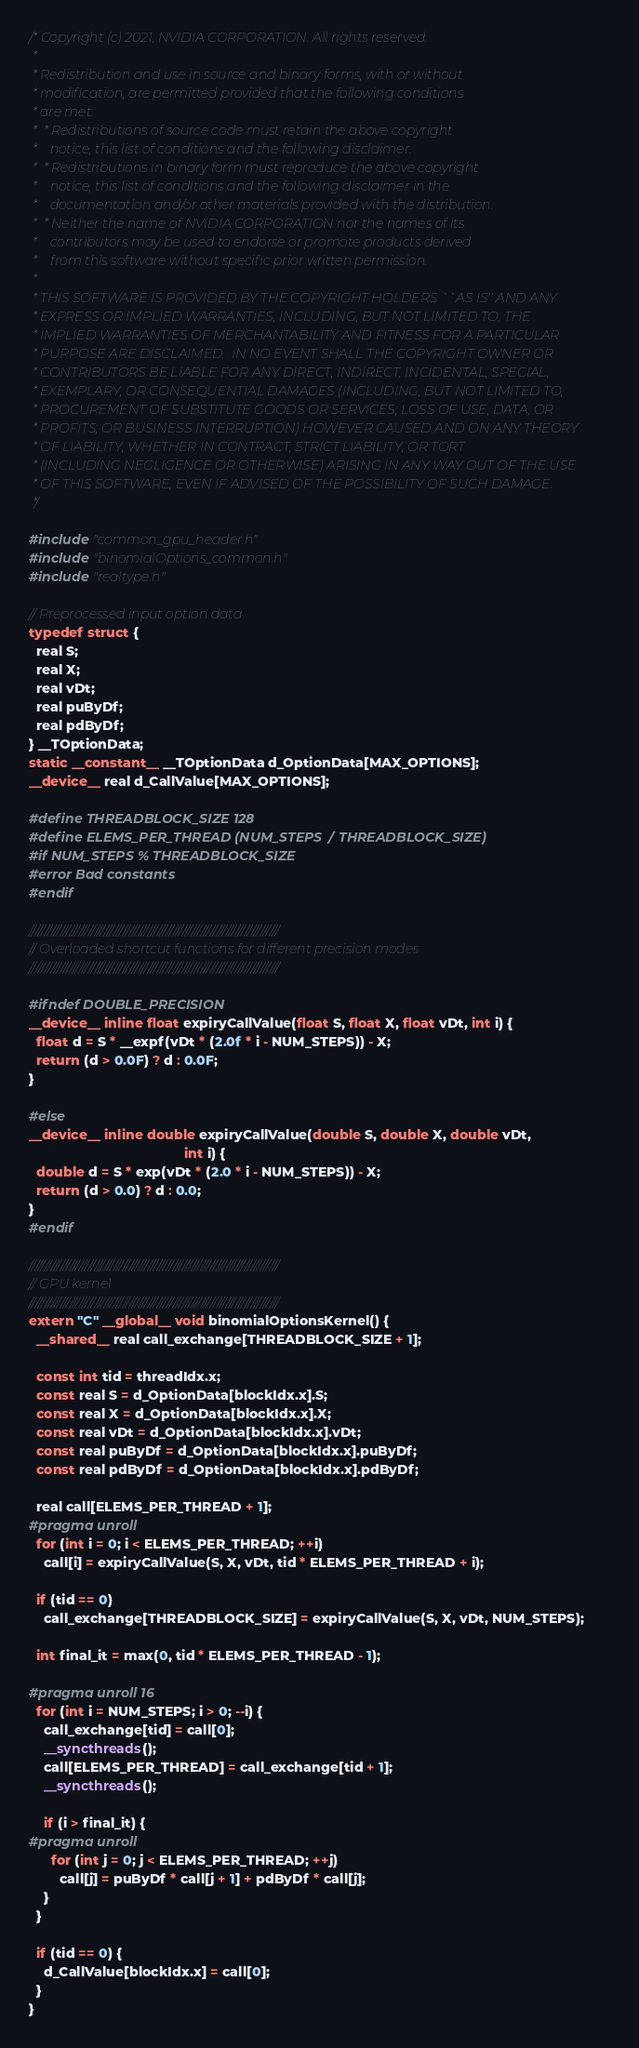Convert code to text. <code><loc_0><loc_0><loc_500><loc_500><_Cuda_>/* Copyright (c) 2021, NVIDIA CORPORATION. All rights reserved.
 *
 * Redistribution and use in source and binary forms, with or without
 * modification, are permitted provided that the following conditions
 * are met:
 *  * Redistributions of source code must retain the above copyright
 *    notice, this list of conditions and the following disclaimer.
 *  * Redistributions in binary form must reproduce the above copyright
 *    notice, this list of conditions and the following disclaimer in the
 *    documentation and/or other materials provided with the distribution.
 *  * Neither the name of NVIDIA CORPORATION nor the names of its
 *    contributors may be used to endorse or promote products derived
 *    from this software without specific prior written permission.
 *
 * THIS SOFTWARE IS PROVIDED BY THE COPYRIGHT HOLDERS ``AS IS'' AND ANY
 * EXPRESS OR IMPLIED WARRANTIES, INCLUDING, BUT NOT LIMITED TO, THE
 * IMPLIED WARRANTIES OF MERCHANTABILITY AND FITNESS FOR A PARTICULAR
 * PURPOSE ARE DISCLAIMED.  IN NO EVENT SHALL THE COPYRIGHT OWNER OR
 * CONTRIBUTORS BE LIABLE FOR ANY DIRECT, INDIRECT, INCIDENTAL, SPECIAL,
 * EXEMPLARY, OR CONSEQUENTIAL DAMAGES (INCLUDING, BUT NOT LIMITED TO,
 * PROCUREMENT OF SUBSTITUTE GOODS OR SERVICES; LOSS OF USE, DATA, OR
 * PROFITS; OR BUSINESS INTERRUPTION) HOWEVER CAUSED AND ON ANY THEORY
 * OF LIABILITY, WHETHER IN CONTRACT, STRICT LIABILITY, OR TORT
 * (INCLUDING NEGLIGENCE OR OTHERWISE) ARISING IN ANY WAY OUT OF THE USE
 * OF THIS SOFTWARE, EVEN IF ADVISED OF THE POSSIBILITY OF SUCH DAMAGE.
 */

#include "common_gpu_header.h"
#include "binomialOptions_common.h"
#include "realtype.h"

// Preprocessed input option data
typedef struct {
  real S;
  real X;
  real vDt;
  real puByDf;
  real pdByDf;
} __TOptionData;
static __constant__ __TOptionData d_OptionData[MAX_OPTIONS];
__device__ real d_CallValue[MAX_OPTIONS];

#define THREADBLOCK_SIZE 128
#define ELEMS_PER_THREAD (NUM_STEPS / THREADBLOCK_SIZE)
#if NUM_STEPS % THREADBLOCK_SIZE
#error Bad constants
#endif

////////////////////////////////////////////////////////////////////////////////
// Overloaded shortcut functions for different precision modes
////////////////////////////////////////////////////////////////////////////////

#ifndef DOUBLE_PRECISION
__device__ inline float expiryCallValue(float S, float X, float vDt, int i) {
  float d = S * __expf(vDt * (2.0f * i - NUM_STEPS)) - X;
  return (d > 0.0F) ? d : 0.0F;
}

#else
__device__ inline double expiryCallValue(double S, double X, double vDt,
                                         int i) {
  double d = S * exp(vDt * (2.0 * i - NUM_STEPS)) - X;
  return (d > 0.0) ? d : 0.0;
}
#endif

////////////////////////////////////////////////////////////////////////////////
// GPU kernel
////////////////////////////////////////////////////////////////////////////////
extern "C" __global__ void binomialOptionsKernel() {
  __shared__ real call_exchange[THREADBLOCK_SIZE + 1];

  const int tid = threadIdx.x;
  const real S = d_OptionData[blockIdx.x].S;
  const real X = d_OptionData[blockIdx.x].X;
  const real vDt = d_OptionData[blockIdx.x].vDt;
  const real puByDf = d_OptionData[blockIdx.x].puByDf;
  const real pdByDf = d_OptionData[blockIdx.x].pdByDf;

  real call[ELEMS_PER_THREAD + 1];
#pragma unroll
  for (int i = 0; i < ELEMS_PER_THREAD; ++i)
    call[i] = expiryCallValue(S, X, vDt, tid * ELEMS_PER_THREAD + i);

  if (tid == 0)
    call_exchange[THREADBLOCK_SIZE] = expiryCallValue(S, X, vDt, NUM_STEPS);

  int final_it = max(0, tid * ELEMS_PER_THREAD - 1);

#pragma unroll 16
  for (int i = NUM_STEPS; i > 0; --i) {
    call_exchange[tid] = call[0];
    __syncthreads();
    call[ELEMS_PER_THREAD] = call_exchange[tid + 1];
    __syncthreads();

    if (i > final_it) {
#pragma unroll
      for (int j = 0; j < ELEMS_PER_THREAD; ++j)
        call[j] = puByDf * call[j + 1] + pdByDf * call[j];
    }
  }

  if (tid == 0) {
    d_CallValue[blockIdx.x] = call[0];
  }
}
</code> 